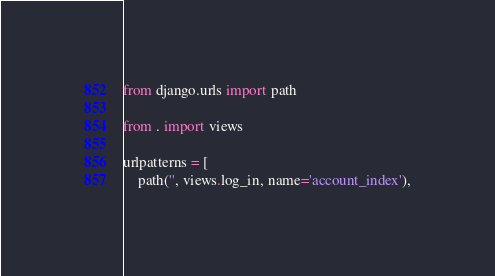<code> <loc_0><loc_0><loc_500><loc_500><_Python_>from django.urls import path

from . import views

urlpatterns = [
    path('', views.log_in, name='account_index'),</code> 